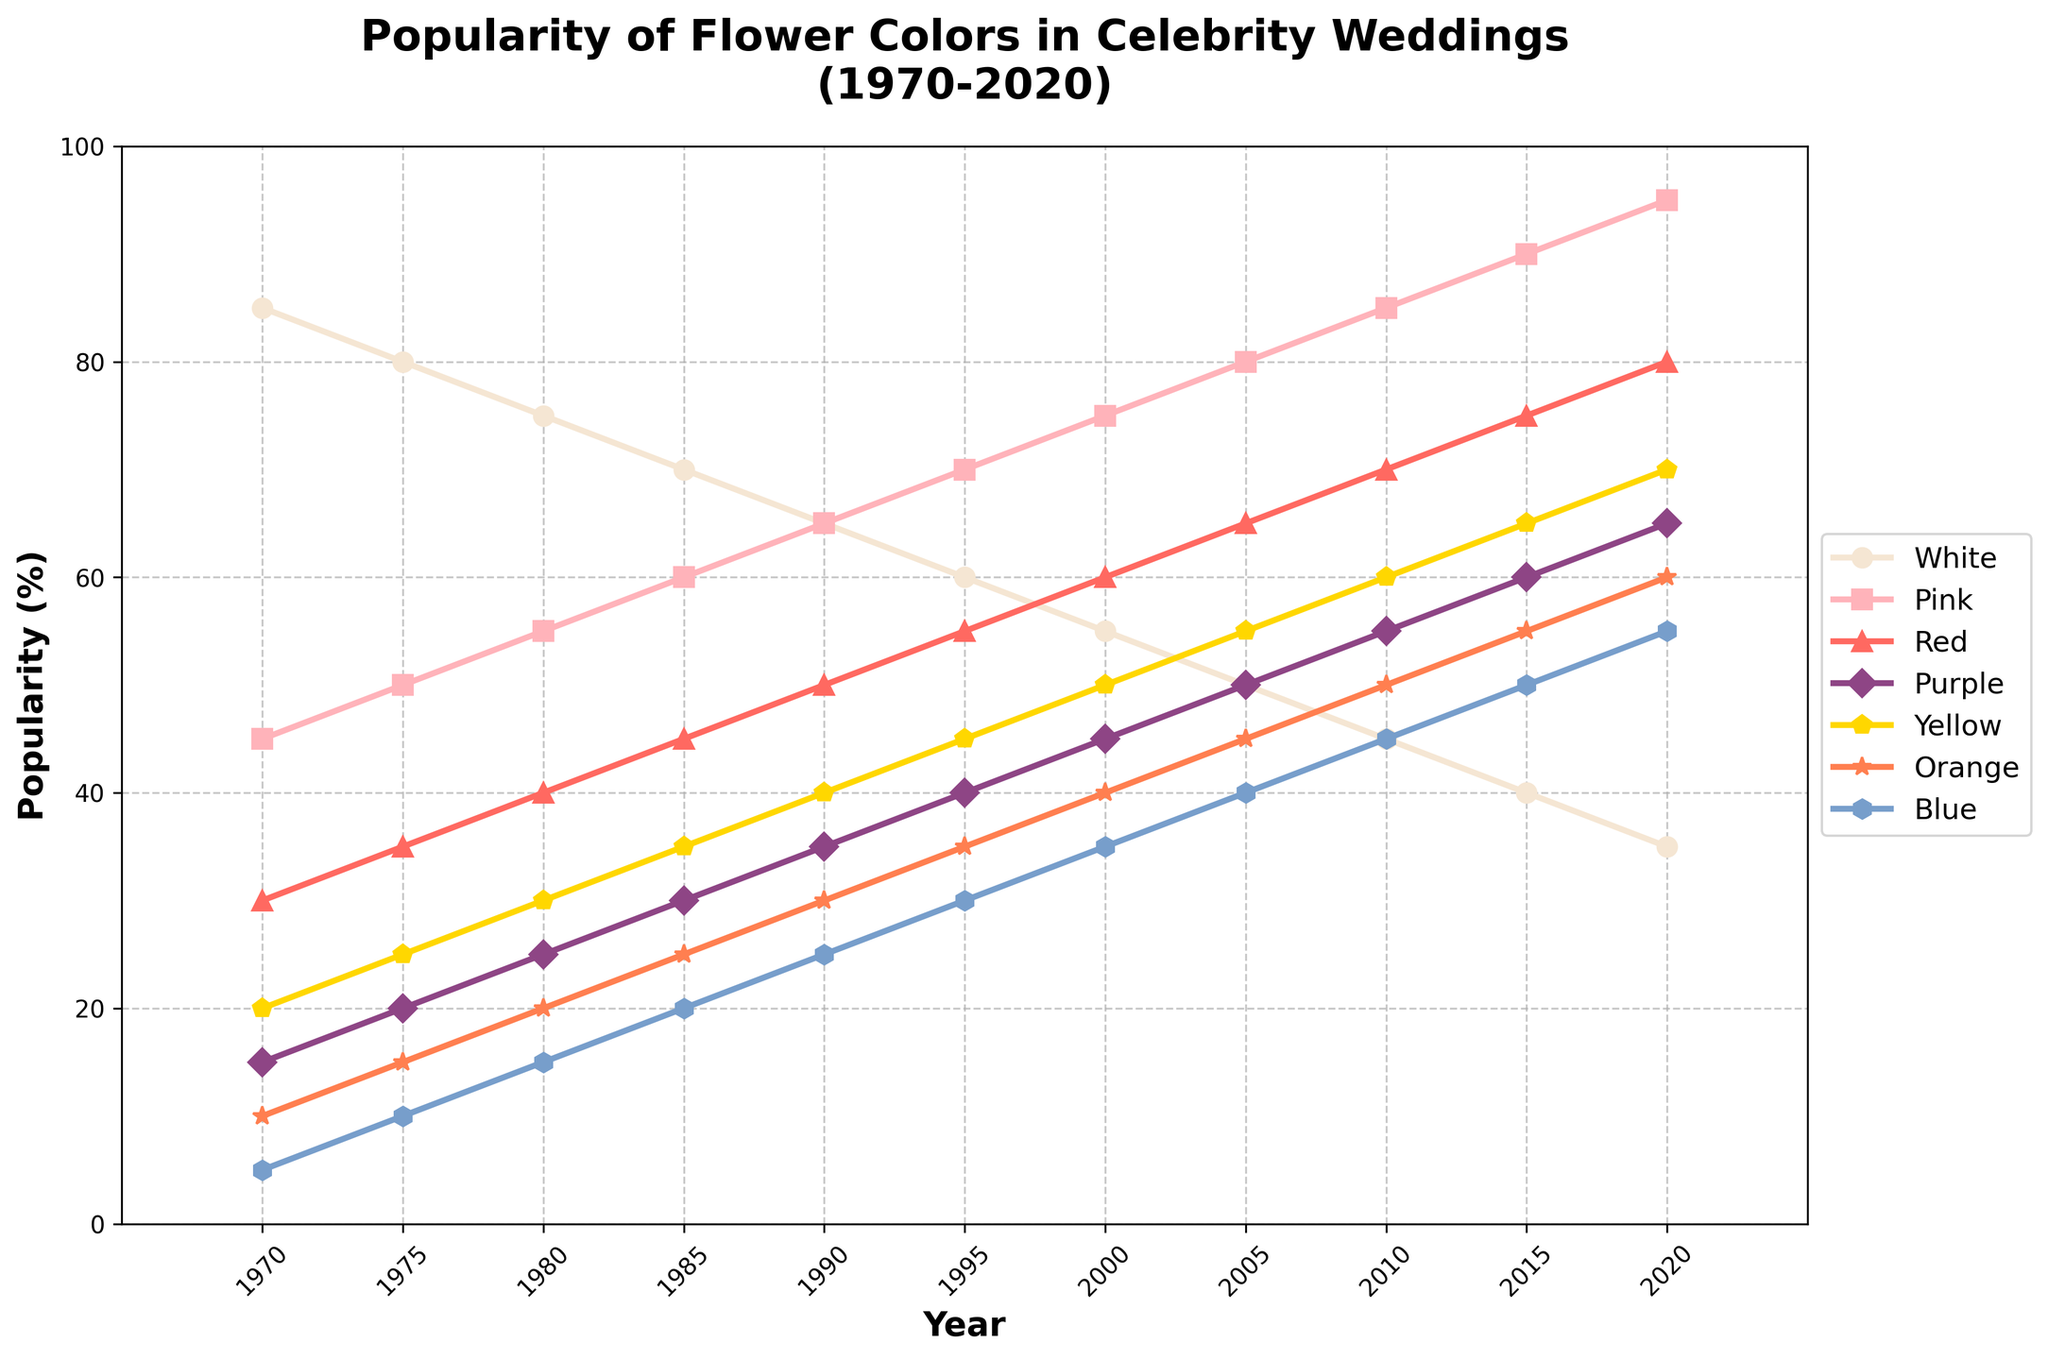Which flower color was the most popular in 1970? In 1970, the chart shows that white flowers had the highest popularity percentage compared to other colors.
Answer: White By how much did the popularity of yellow flowers change from 1975 to 2020? In 1975, the popularity of yellow flowers was 25%, and in 2020 it was 70%. The difference is calculated as 70% - 25%, which results in a 45% increase.
Answer: 45% Which flower color saw the largest increase in popularity from 1975 to 2015? By comparing the popularity of all flower colors in 1975 and 2015, it shows that pink flowers increased from 50% to 90%, making it the largest increase, with a change of 40%.
Answer: Pink Did any flower color's popularity remain constant throughout the years? All flower colors show a trend of increasing or decreasing popularity when observed from 1970 to 2020. Therefore, none of the flower colors' popularity remained constant.
Answer: No Which flower color had the highest popularity in 2005? In 2005, the chart shows that pink flowers had the highest popularity percentage compared to other colors.
Answer: Pink How many flower colors had a popularity of over 60% in 2020? In 2020, the chart shows that white (35%), pink (95%), red (80%), purple (65%), and yellow (70%). Therefore, five flower colors had a popularity of over 60%.
Answer: Five What is the trend of blue flowers' popularity over the years? Observing the chart, the popularity of blue flowers shows an increasing trend from 1970 (5%) to 2020 (55%).
Answer: Increasing What was the average popularity of purple flowers in 1980, 1990, and 2000? The popularity of purple flowers in 1980 was 25%, in 1990 it was 35%, and in 2000 it was 45%. To find the average: (25% + 35% + 45%) / 3 = 35%.
Answer: 35% Which flower color had the sharpest decline in popularity between 1980 and 1995? Comparing the chart, white flowers declined from 75% in 1980 to 60% in 1995, a decline of 15%, which is the sharpest decline among all colors.
Answer: White What was the popularity difference between pink and red flowers in 2015? In 2015, the chart shows that the popularity of pink and red flowers was 90% and 75%, respectively. The difference is 90% - 75% = 15%.
Answer: 15% 